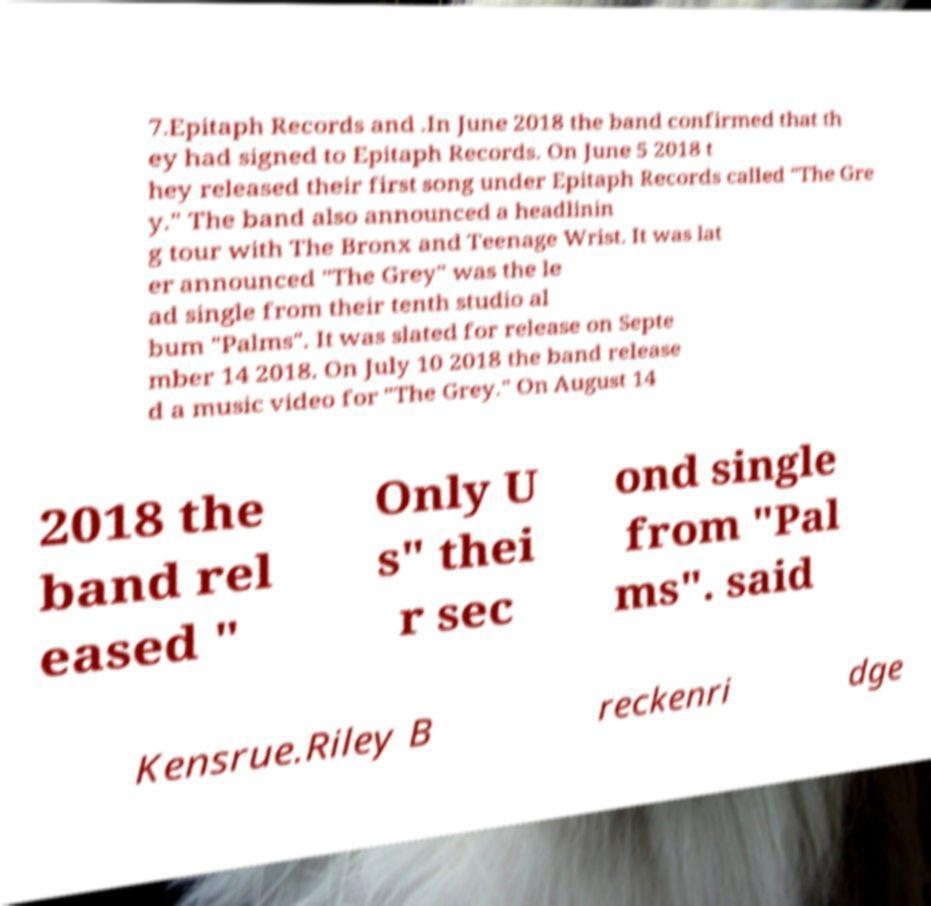What messages or text are displayed in this image? I need them in a readable, typed format. 7.Epitaph Records and .In June 2018 the band confirmed that th ey had signed to Epitaph Records. On June 5 2018 t hey released their first song under Epitaph Records called "The Gre y." The band also announced a headlinin g tour with The Bronx and Teenage Wrist. It was lat er announced "The Grey" was the le ad single from their tenth studio al bum "Palms". It was slated for release on Septe mber 14 2018. On July 10 2018 the band release d a music video for "The Grey." On August 14 2018 the band rel eased " Only U s" thei r sec ond single from "Pal ms". said Kensrue.Riley B reckenri dge 